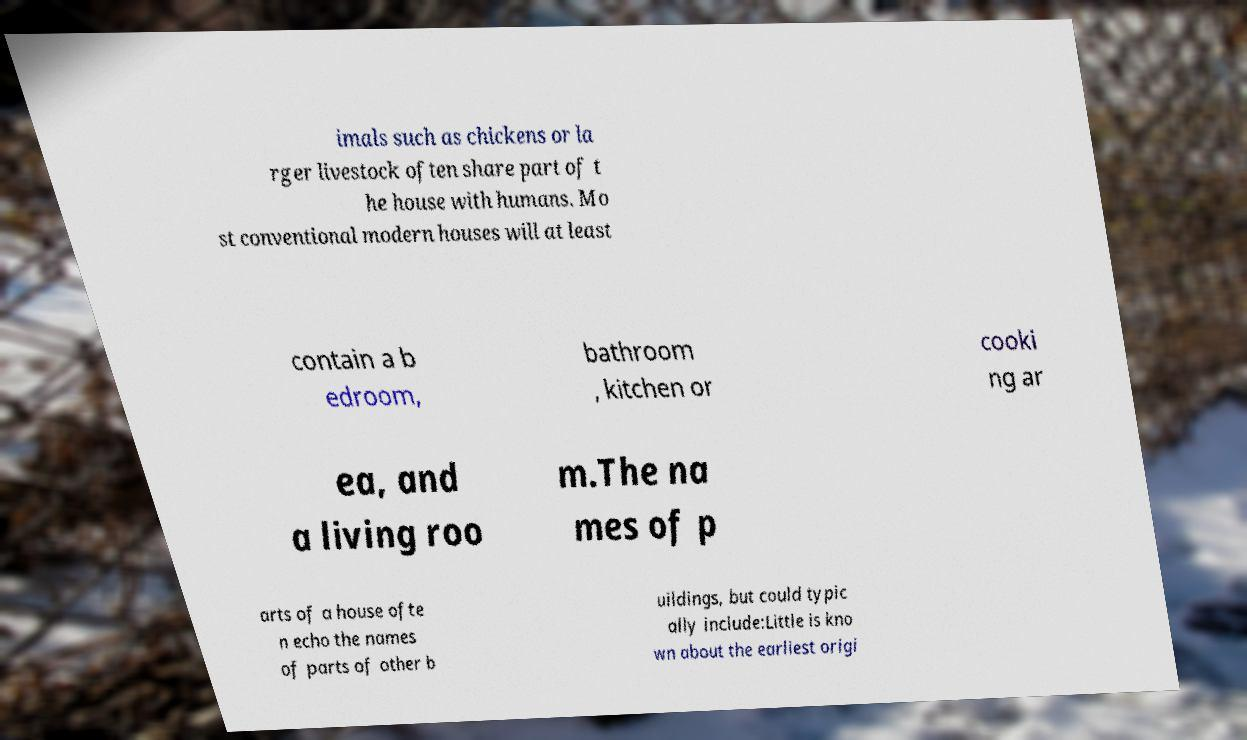Could you assist in decoding the text presented in this image and type it out clearly? imals such as chickens or la rger livestock often share part of t he house with humans. Mo st conventional modern houses will at least contain a b edroom, bathroom , kitchen or cooki ng ar ea, and a living roo m.The na mes of p arts of a house ofte n echo the names of parts of other b uildings, but could typic ally include:Little is kno wn about the earliest origi 